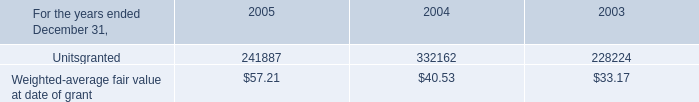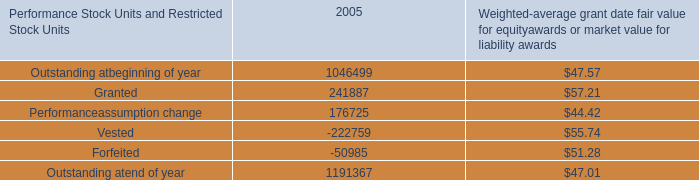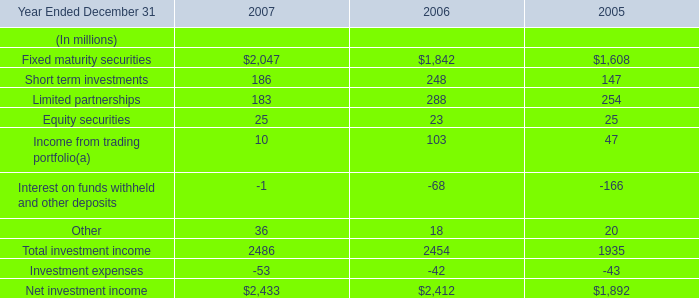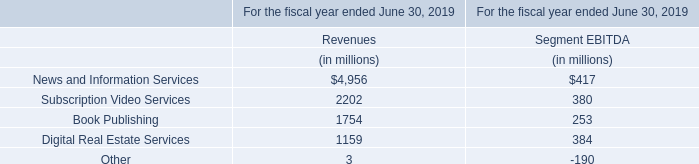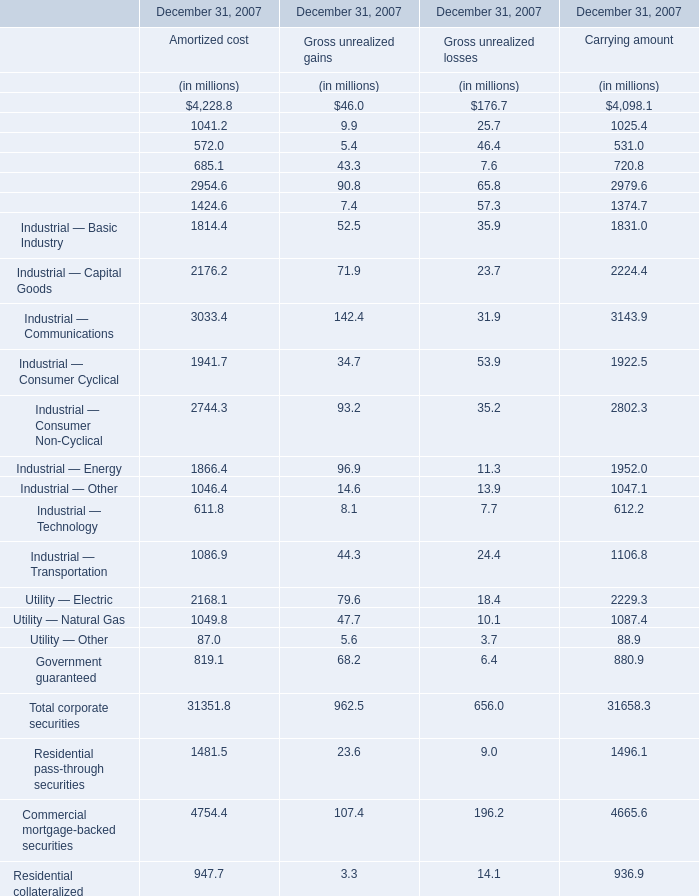What was the total amount of the Utility — Electric in the sections where Finance — Banking greater than 4000? (in million) 
Computations: (2168.1 + 2229.3)
Answer: 4397.4. 